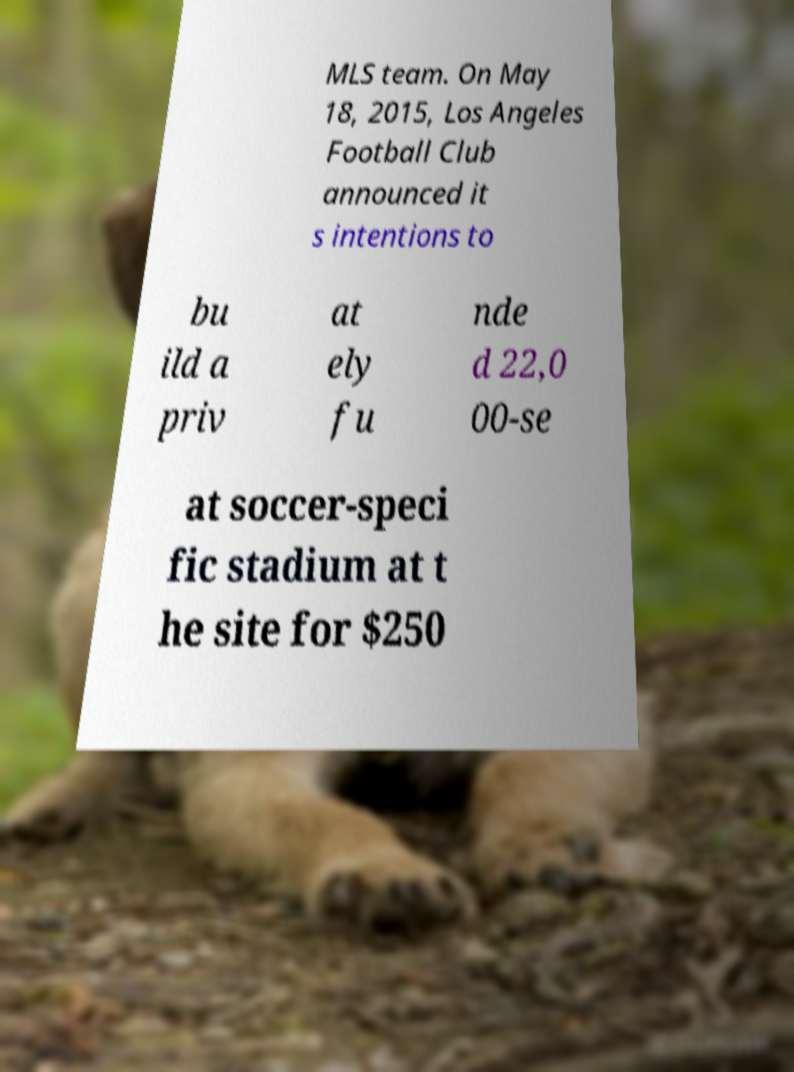Can you read and provide the text displayed in the image?This photo seems to have some interesting text. Can you extract and type it out for me? MLS team. On May 18, 2015, Los Angeles Football Club announced it s intentions to bu ild a priv at ely fu nde d 22,0 00-se at soccer-speci fic stadium at t he site for $250 